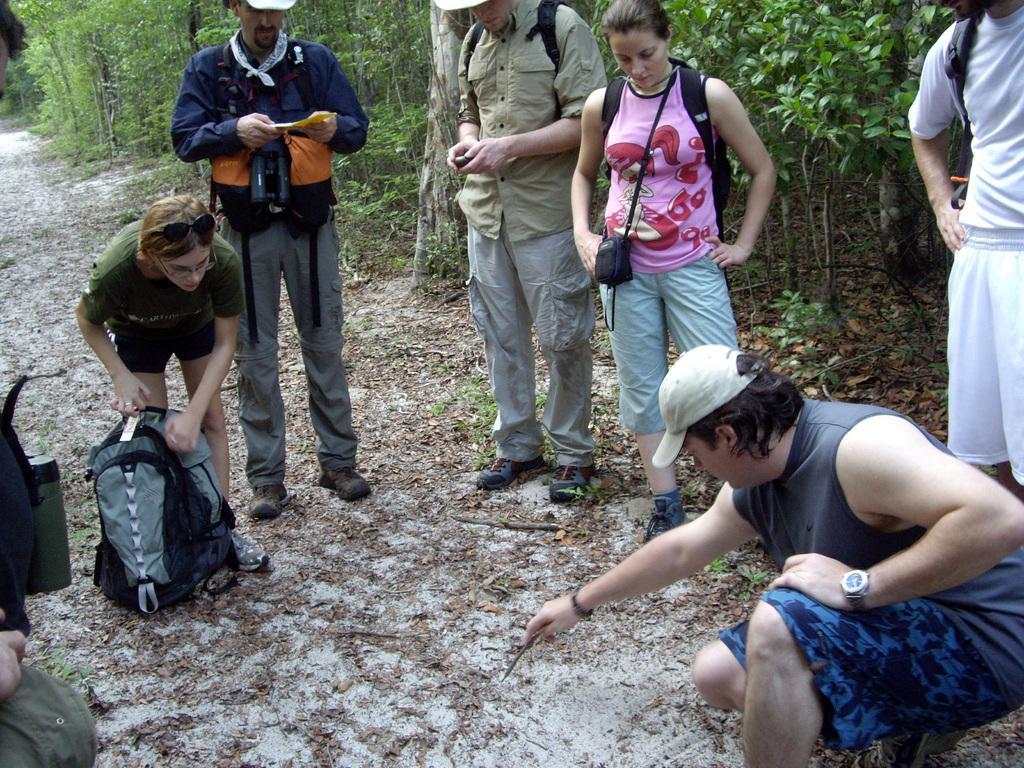Could you give a brief overview of what you see in this image? In this image there are a few people standing with their luggage on the surface. In the background there are trees. 